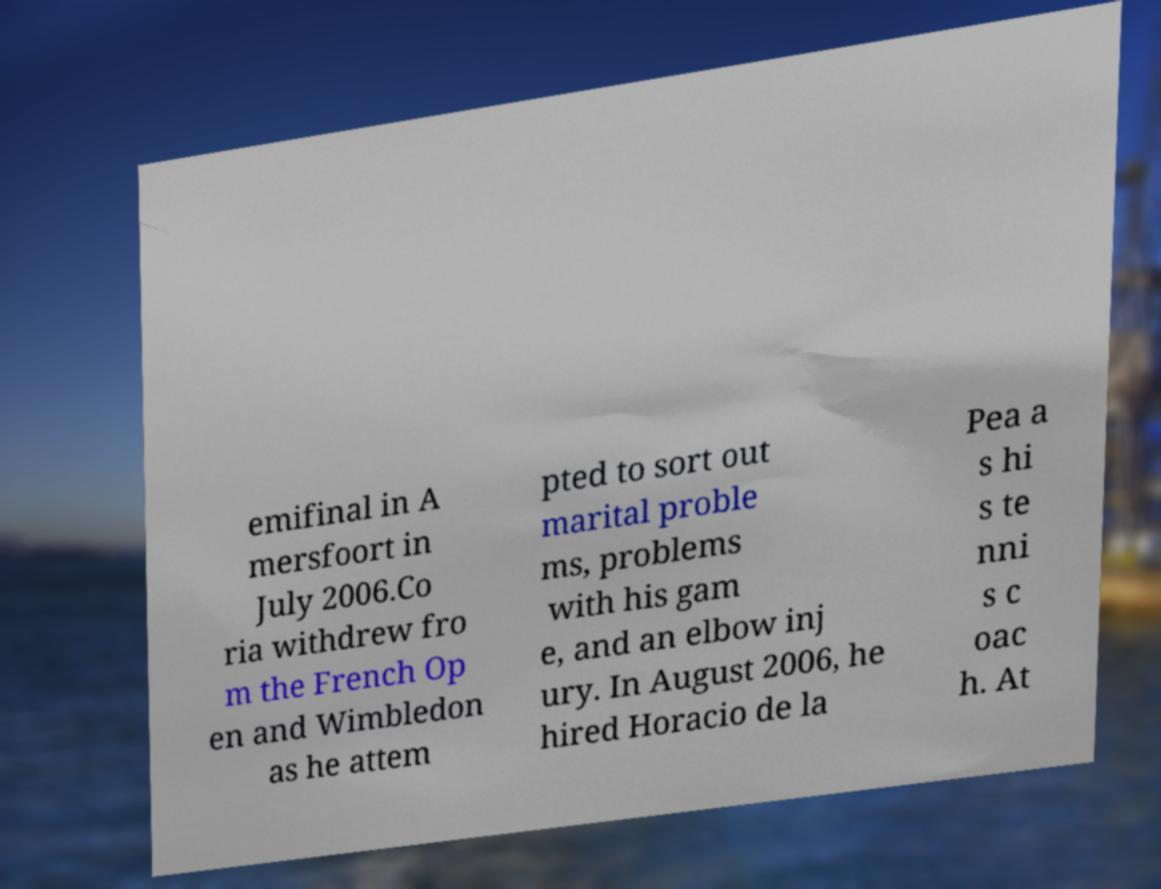There's text embedded in this image that I need extracted. Can you transcribe it verbatim? emifinal in A mersfoort in July 2006.Co ria withdrew fro m the French Op en and Wimbledon as he attem pted to sort out marital proble ms, problems with his gam e, and an elbow inj ury. In August 2006, he hired Horacio de la Pea a s hi s te nni s c oac h. At 